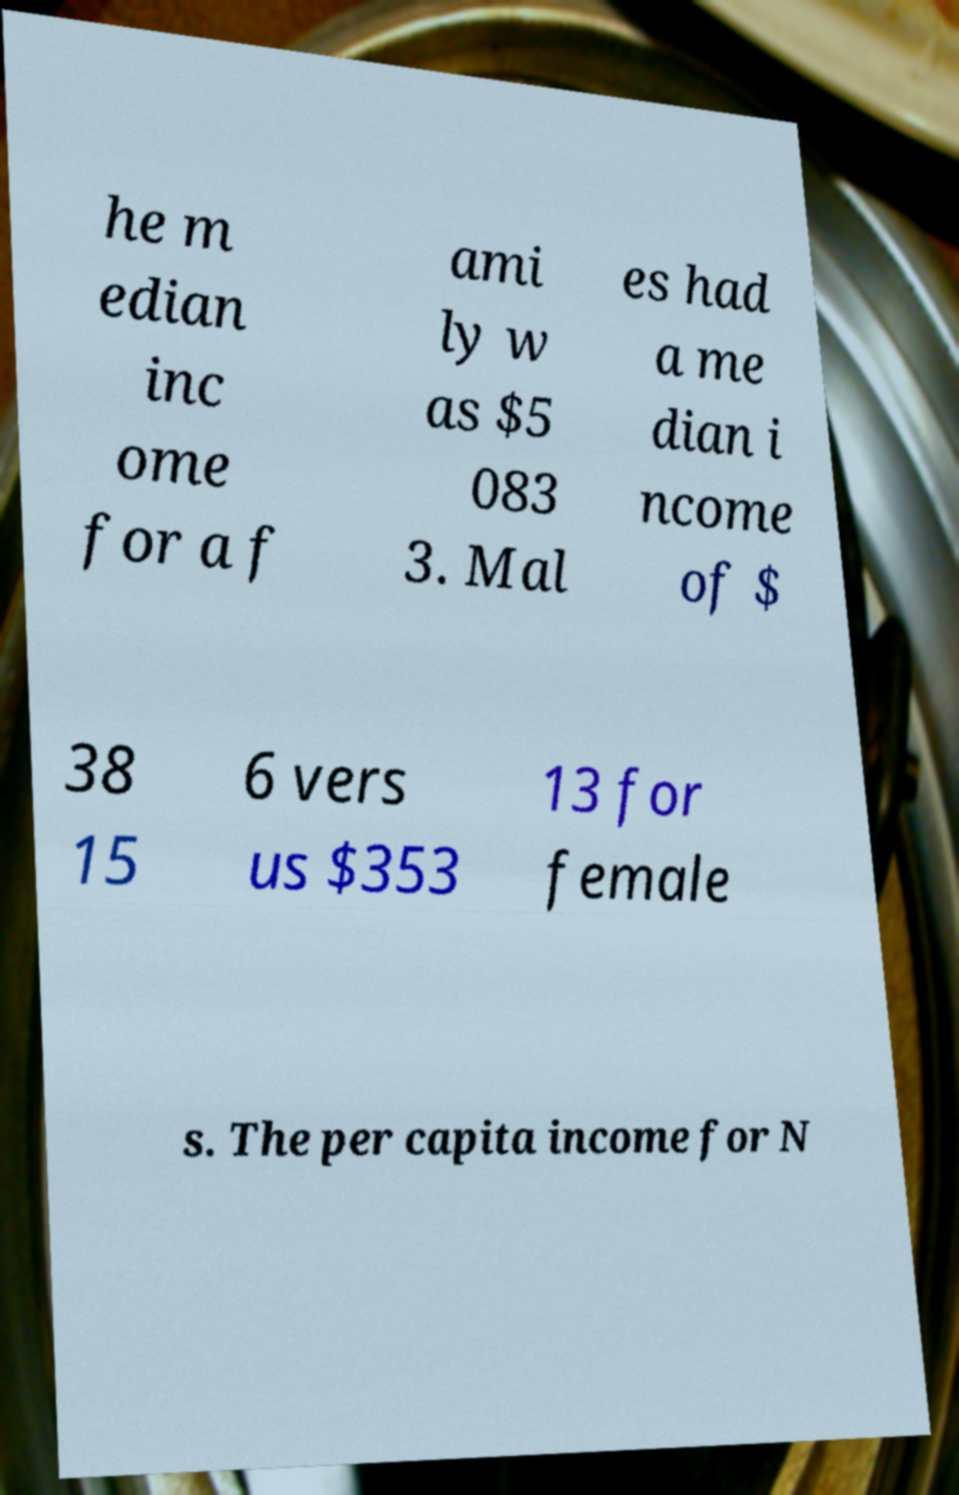Could you assist in decoding the text presented in this image and type it out clearly? he m edian inc ome for a f ami ly w as $5 083 3. Mal es had a me dian i ncome of $ 38 15 6 vers us $353 13 for female s. The per capita income for N 